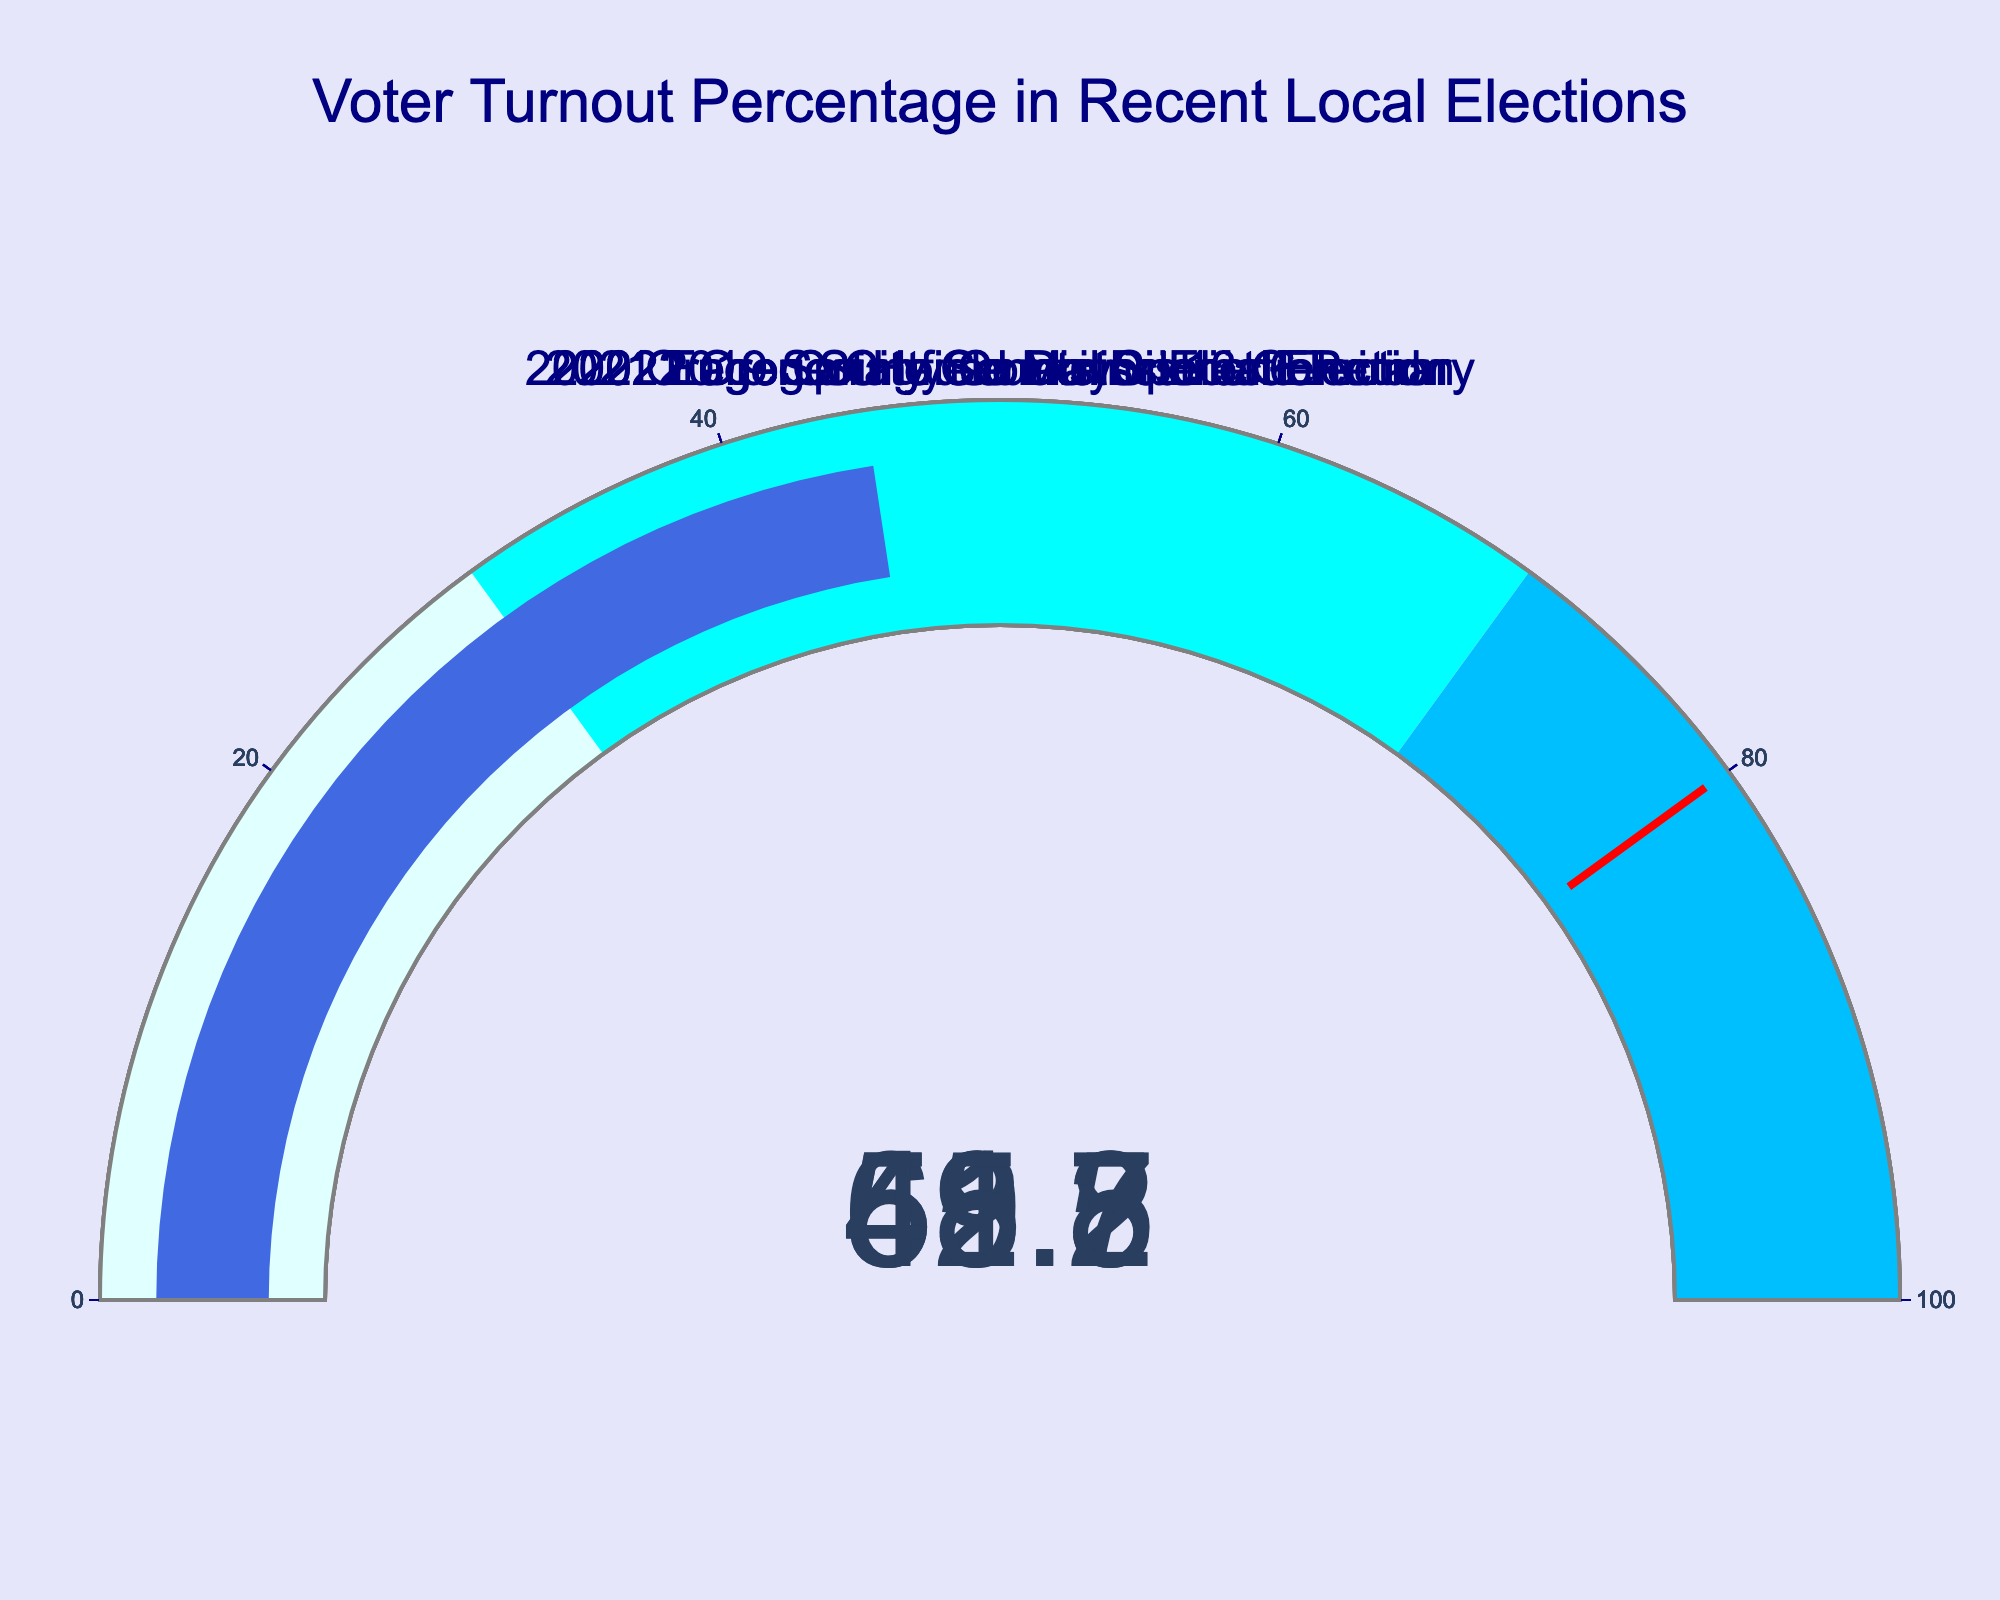How many elections are depicted in the figure? Count the number of gauges shown in the figure.
Answer: 5 What is the title of the chart? Read the title text present at the top of the chart.
Answer: Voter Turnout Percentage in Recent Local Elections Which election had the highest voter turnout percentage? Look for the gauge with the highest value in the figure.
Answer: 2022 Oregon House District 13 General Which election had the lowest voter turnout percentage? Look for the gauge with the lowest value in the figure.
Answer: 2021 Eugene City Council Special Election What is the average voter turnout percentage across all depicted elections? Add each turnout percentage (68.5, 52.3, 41.7, 59.8, 45.2) and divide by the number of elections (5). (68.5 + 52.3 + 41.7 + 59.8 + 45.2) / 5 = 53.5
Answer: 53.5 Is the voter turnout for the 2020 Oregon State Senate District 6 Primary above 60%? Refer to the gauge for the 2020 Oregon State Senate District 6 Primary and see if the number exceeds 60.
Answer: No By how much did the voter turnout percentage for the 2022 Oregon House District 13 General election exceed that of the 2021 Eugene City Council Special Election? Subtract the turnout percentage of the 2021 Eugene City Council Special Election (41.7) from that of the 2022 Oregon House District 13 General (68.5). 68.5 - 41.7 = 26.8
Answer: 26.8 What colors indicate the different ranges of voter turnout percentages in the gauges? Identify the different colors used to represent ranges in the gauges.
Answer: Lightcyan, Cyan, Deepskyblue Do any of the elections displayed surpass the threshold value of 80% voter turnout? Check for gauges where indicated voter turnout percentages exceed the threshold mark of 80%.
Answer: No 